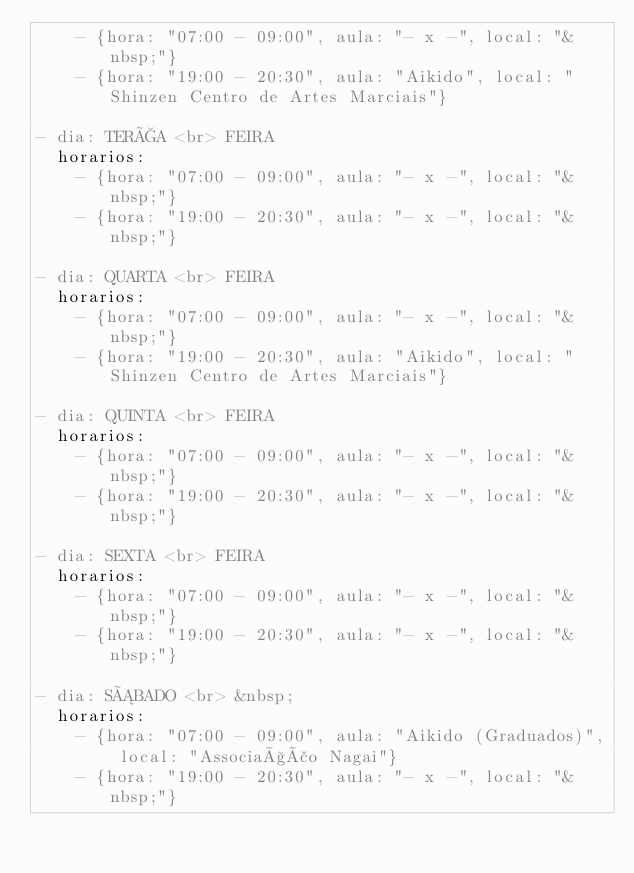Convert code to text. <code><loc_0><loc_0><loc_500><loc_500><_YAML_>    - {hora: "07:00 - 09:00", aula: "- x -", local: "&nbsp;"}
    - {hora: "19:00 - 20:30", aula: "Aikido", local: "Shinzen Centro de Artes Marciais"}

- dia: TERÇA <br> FEIRA
  horarios:
    - {hora: "07:00 - 09:00", aula: "- x -", local: "&nbsp;"}
    - {hora: "19:00 - 20:30", aula: "- x -", local: "&nbsp;"}

- dia: QUARTA <br> FEIRA
  horarios:
    - {hora: "07:00 - 09:00", aula: "- x -", local: "&nbsp;"}
    - {hora: "19:00 - 20:30", aula: "Aikido", local: "Shinzen Centro de Artes Marciais"}

- dia: QUINTA <br> FEIRA
  horarios:
    - {hora: "07:00 - 09:00", aula: "- x -", local: "&nbsp;"}
    - {hora: "19:00 - 20:30", aula: "- x -", local: "&nbsp;"}

- dia: SEXTA <br> FEIRA
  horarios:
    - {hora: "07:00 - 09:00", aula: "- x -", local: "&nbsp;"}
    - {hora: "19:00 - 20:30", aula: "- x -", local: "&nbsp;"}

- dia: SÁBADO <br> &nbsp;
  horarios:
    - {hora: "07:00 - 09:00", aula: "Aikido (Graduados)", local: "Associação Nagai"}
    - {hora: "19:00 - 20:30", aula: "- x -", local: "&nbsp;"}
</code> 